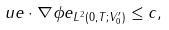Convert formula to latex. <formula><loc_0><loc_0><loc_500><loc_500>& \| \ u e \cdot \nabla \phi e \| _ { L ^ { 2 } ( 0 , T ; V _ { 0 } ^ { \prime } ) } \leq c ,</formula> 